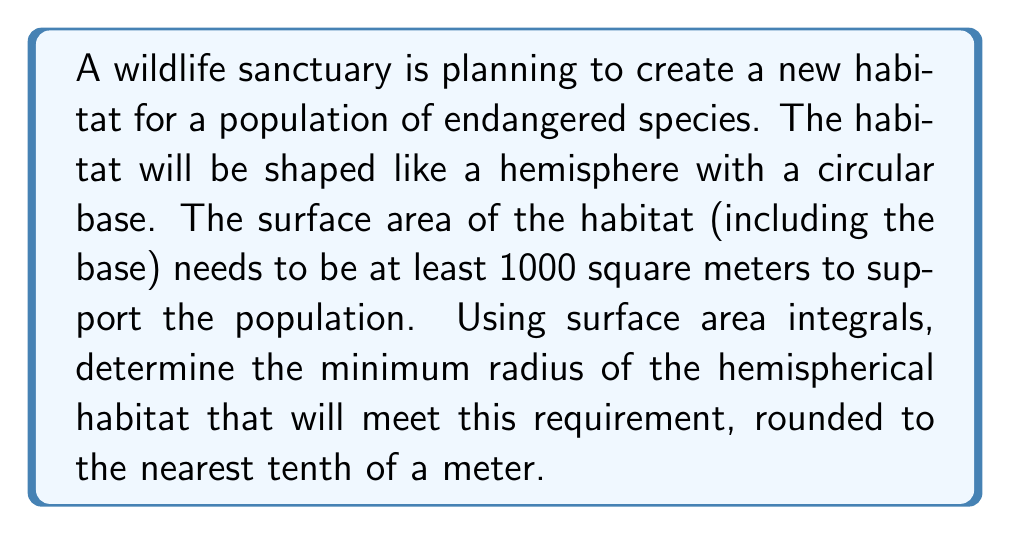Can you solve this math problem? Let's approach this step-by-step:

1) The surface area of a hemisphere includes the curved surface and the circular base. We need to set up an integral for the curved surface and add it to the area of the base.

2) For a hemisphere with radius $r$, we can use spherical coordinates to set up the surface area integral:

   $$A_{curved} = \int_0^{\pi/2} \int_0^{2\pi} r^2 \sin\phi \, d\theta \, d\phi$$

3) The area of the circular base is simply $\pi r^2$.

4) Evaluating the double integral:
   
   $$\begin{align}
   A_{curved} &= \int_0^{\pi/2} \int_0^{2\pi} r^2 \sin\phi \, d\theta \, d\phi \\
   &= r^2 \int_0^{\pi/2} \sin\phi \left[\int_0^{2\pi} d\theta\right] d\phi \\
   &= 2\pi r^2 \int_0^{\pi/2} \sin\phi \, d\phi \\
   &= 2\pi r^2 [-\cos\phi]_0^{\pi/2} \\
   &= 2\pi r^2 (1 - 0) = 2\pi r^2
   \end{align}$$

5) The total surface area is:

   $$A_{total} = A_{curved} + A_{base} = 2\pi r^2 + \pi r^2 = 3\pi r^2$$

6) We want this to be at least 1000 m²:

   $$3\pi r^2 \geq 1000$$

7) Solving for $r$:

   $$\begin{align}
   r^2 &\geq \frac{1000}{3\pi} \\
   r &\geq \sqrt{\frac{1000}{3\pi}} \approx 10.2799 \text{ m}
   \end{align}$$

8) Rounding to the nearest tenth of a meter, we get 10.3 m.
Answer: 10.3 m 